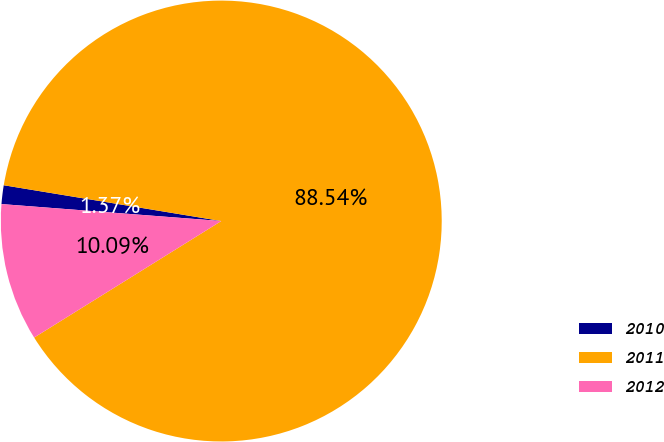Convert chart. <chart><loc_0><loc_0><loc_500><loc_500><pie_chart><fcel>2010<fcel>2011<fcel>2012<nl><fcel>1.37%<fcel>88.54%<fcel>10.09%<nl></chart> 